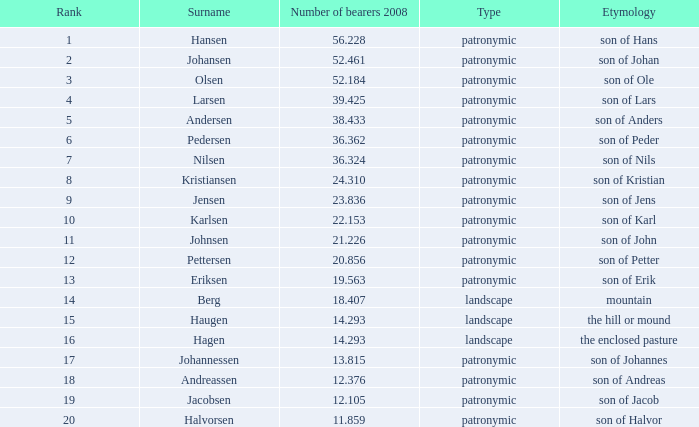What is the kind, when standing is higher than 6, when bearer total in 2008 is greater than 1 Patronymic. 